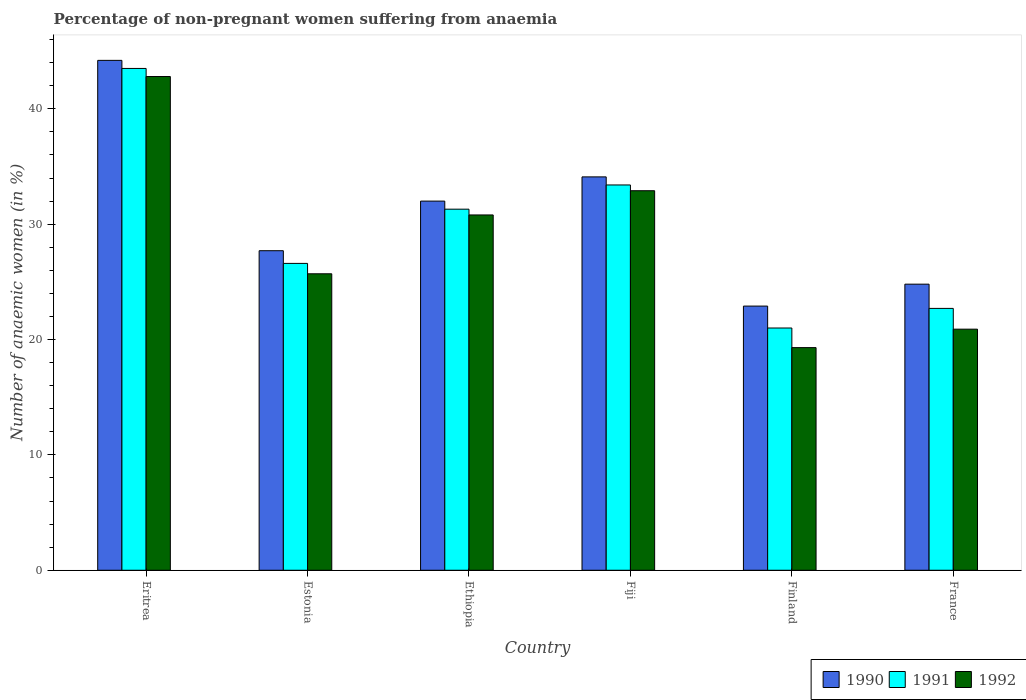How many different coloured bars are there?
Make the answer very short. 3. How many groups of bars are there?
Ensure brevity in your answer.  6. Are the number of bars on each tick of the X-axis equal?
Give a very brief answer. Yes. How many bars are there on the 5th tick from the right?
Provide a short and direct response. 3. What is the label of the 2nd group of bars from the left?
Provide a short and direct response. Estonia. What is the percentage of non-pregnant women suffering from anaemia in 1991 in Fiji?
Your answer should be very brief. 33.4. Across all countries, what is the maximum percentage of non-pregnant women suffering from anaemia in 1990?
Provide a succinct answer. 44.2. Across all countries, what is the minimum percentage of non-pregnant women suffering from anaemia in 1990?
Provide a short and direct response. 22.9. In which country was the percentage of non-pregnant women suffering from anaemia in 1990 maximum?
Give a very brief answer. Eritrea. In which country was the percentage of non-pregnant women suffering from anaemia in 1992 minimum?
Your answer should be very brief. Finland. What is the total percentage of non-pregnant women suffering from anaemia in 1991 in the graph?
Ensure brevity in your answer.  178.5. What is the difference between the percentage of non-pregnant women suffering from anaemia in 1990 in Finland and that in France?
Your answer should be very brief. -1.9. What is the average percentage of non-pregnant women suffering from anaemia in 1991 per country?
Keep it short and to the point. 29.75. In how many countries, is the percentage of non-pregnant women suffering from anaemia in 1992 greater than 44 %?
Provide a succinct answer. 0. What is the ratio of the percentage of non-pregnant women suffering from anaemia in 1991 in Eritrea to that in Estonia?
Provide a succinct answer. 1.64. Is the percentage of non-pregnant women suffering from anaemia in 1990 in Fiji less than that in France?
Your answer should be compact. No. What is the difference between the highest and the second highest percentage of non-pregnant women suffering from anaemia in 1990?
Give a very brief answer. -2.1. What is the difference between the highest and the lowest percentage of non-pregnant women suffering from anaemia in 1990?
Ensure brevity in your answer.  21.3. Is the sum of the percentage of non-pregnant women suffering from anaemia in 1991 in Eritrea and Fiji greater than the maximum percentage of non-pregnant women suffering from anaemia in 1992 across all countries?
Offer a very short reply. Yes. What does the 3rd bar from the right in Estonia represents?
Provide a succinct answer. 1990. Is it the case that in every country, the sum of the percentage of non-pregnant women suffering from anaemia in 1992 and percentage of non-pregnant women suffering from anaemia in 1991 is greater than the percentage of non-pregnant women suffering from anaemia in 1990?
Keep it short and to the point. Yes. How many bars are there?
Ensure brevity in your answer.  18. How many countries are there in the graph?
Your answer should be compact. 6. Are the values on the major ticks of Y-axis written in scientific E-notation?
Your answer should be compact. No. What is the title of the graph?
Your answer should be compact. Percentage of non-pregnant women suffering from anaemia. What is the label or title of the X-axis?
Provide a short and direct response. Country. What is the label or title of the Y-axis?
Your answer should be compact. Number of anaemic women (in %). What is the Number of anaemic women (in %) in 1990 in Eritrea?
Your answer should be compact. 44.2. What is the Number of anaemic women (in %) of 1991 in Eritrea?
Make the answer very short. 43.5. What is the Number of anaemic women (in %) of 1992 in Eritrea?
Your response must be concise. 42.8. What is the Number of anaemic women (in %) of 1990 in Estonia?
Make the answer very short. 27.7. What is the Number of anaemic women (in %) of 1991 in Estonia?
Your response must be concise. 26.6. What is the Number of anaemic women (in %) of 1992 in Estonia?
Make the answer very short. 25.7. What is the Number of anaemic women (in %) in 1991 in Ethiopia?
Your answer should be very brief. 31.3. What is the Number of anaemic women (in %) of 1992 in Ethiopia?
Offer a very short reply. 30.8. What is the Number of anaemic women (in %) of 1990 in Fiji?
Keep it short and to the point. 34.1. What is the Number of anaemic women (in %) in 1991 in Fiji?
Keep it short and to the point. 33.4. What is the Number of anaemic women (in %) of 1992 in Fiji?
Offer a terse response. 32.9. What is the Number of anaemic women (in %) of 1990 in Finland?
Give a very brief answer. 22.9. What is the Number of anaemic women (in %) in 1991 in Finland?
Your response must be concise. 21. What is the Number of anaemic women (in %) in 1992 in Finland?
Keep it short and to the point. 19.3. What is the Number of anaemic women (in %) in 1990 in France?
Ensure brevity in your answer.  24.8. What is the Number of anaemic women (in %) in 1991 in France?
Offer a terse response. 22.7. What is the Number of anaemic women (in %) of 1992 in France?
Your answer should be compact. 20.9. Across all countries, what is the maximum Number of anaemic women (in %) in 1990?
Your response must be concise. 44.2. Across all countries, what is the maximum Number of anaemic women (in %) of 1991?
Your response must be concise. 43.5. Across all countries, what is the maximum Number of anaemic women (in %) of 1992?
Keep it short and to the point. 42.8. Across all countries, what is the minimum Number of anaemic women (in %) in 1990?
Your answer should be very brief. 22.9. Across all countries, what is the minimum Number of anaemic women (in %) in 1991?
Give a very brief answer. 21. Across all countries, what is the minimum Number of anaemic women (in %) in 1992?
Your answer should be compact. 19.3. What is the total Number of anaemic women (in %) of 1990 in the graph?
Your answer should be very brief. 185.7. What is the total Number of anaemic women (in %) in 1991 in the graph?
Offer a terse response. 178.5. What is the total Number of anaemic women (in %) in 1992 in the graph?
Offer a terse response. 172.4. What is the difference between the Number of anaemic women (in %) of 1991 in Eritrea and that in Estonia?
Give a very brief answer. 16.9. What is the difference between the Number of anaemic women (in %) of 1992 in Eritrea and that in Estonia?
Provide a short and direct response. 17.1. What is the difference between the Number of anaemic women (in %) of 1991 in Eritrea and that in Ethiopia?
Your answer should be very brief. 12.2. What is the difference between the Number of anaemic women (in %) of 1992 in Eritrea and that in Ethiopia?
Give a very brief answer. 12. What is the difference between the Number of anaemic women (in %) of 1991 in Eritrea and that in Fiji?
Make the answer very short. 10.1. What is the difference between the Number of anaemic women (in %) of 1990 in Eritrea and that in Finland?
Provide a succinct answer. 21.3. What is the difference between the Number of anaemic women (in %) in 1991 in Eritrea and that in Finland?
Your response must be concise. 22.5. What is the difference between the Number of anaemic women (in %) of 1992 in Eritrea and that in Finland?
Offer a terse response. 23.5. What is the difference between the Number of anaemic women (in %) in 1990 in Eritrea and that in France?
Your answer should be compact. 19.4. What is the difference between the Number of anaemic women (in %) of 1991 in Eritrea and that in France?
Provide a short and direct response. 20.8. What is the difference between the Number of anaemic women (in %) in 1992 in Eritrea and that in France?
Provide a succinct answer. 21.9. What is the difference between the Number of anaemic women (in %) of 1991 in Estonia and that in Ethiopia?
Provide a short and direct response. -4.7. What is the difference between the Number of anaemic women (in %) in 1992 in Estonia and that in Ethiopia?
Offer a terse response. -5.1. What is the difference between the Number of anaemic women (in %) in 1991 in Estonia and that in Fiji?
Give a very brief answer. -6.8. What is the difference between the Number of anaemic women (in %) in 1992 in Estonia and that in Fiji?
Your answer should be compact. -7.2. What is the difference between the Number of anaemic women (in %) of 1990 in Estonia and that in Finland?
Keep it short and to the point. 4.8. What is the difference between the Number of anaemic women (in %) in 1991 in Estonia and that in Finland?
Keep it short and to the point. 5.6. What is the difference between the Number of anaemic women (in %) in 1992 in Estonia and that in Finland?
Make the answer very short. 6.4. What is the difference between the Number of anaemic women (in %) in 1990 in Estonia and that in France?
Keep it short and to the point. 2.9. What is the difference between the Number of anaemic women (in %) of 1992 in Estonia and that in France?
Your response must be concise. 4.8. What is the difference between the Number of anaemic women (in %) in 1991 in Ethiopia and that in Fiji?
Offer a very short reply. -2.1. What is the difference between the Number of anaemic women (in %) in 1991 in Ethiopia and that in Finland?
Provide a succinct answer. 10.3. What is the difference between the Number of anaemic women (in %) of 1992 in Ethiopia and that in Finland?
Give a very brief answer. 11.5. What is the difference between the Number of anaemic women (in %) of 1990 in Ethiopia and that in France?
Offer a very short reply. 7.2. What is the difference between the Number of anaemic women (in %) in 1991 in Ethiopia and that in France?
Provide a succinct answer. 8.6. What is the difference between the Number of anaemic women (in %) of 1990 in Fiji and that in Finland?
Offer a terse response. 11.2. What is the difference between the Number of anaemic women (in %) in 1991 in Fiji and that in Finland?
Make the answer very short. 12.4. What is the difference between the Number of anaemic women (in %) of 1991 in Fiji and that in France?
Your answer should be compact. 10.7. What is the difference between the Number of anaemic women (in %) of 1990 in Eritrea and the Number of anaemic women (in %) of 1992 in Estonia?
Keep it short and to the point. 18.5. What is the difference between the Number of anaemic women (in %) of 1990 in Eritrea and the Number of anaemic women (in %) of 1992 in Ethiopia?
Keep it short and to the point. 13.4. What is the difference between the Number of anaemic women (in %) of 1990 in Eritrea and the Number of anaemic women (in %) of 1991 in Finland?
Provide a succinct answer. 23.2. What is the difference between the Number of anaemic women (in %) in 1990 in Eritrea and the Number of anaemic women (in %) in 1992 in Finland?
Offer a terse response. 24.9. What is the difference between the Number of anaemic women (in %) of 1991 in Eritrea and the Number of anaemic women (in %) of 1992 in Finland?
Provide a short and direct response. 24.2. What is the difference between the Number of anaemic women (in %) in 1990 in Eritrea and the Number of anaemic women (in %) in 1992 in France?
Give a very brief answer. 23.3. What is the difference between the Number of anaemic women (in %) in 1991 in Eritrea and the Number of anaemic women (in %) in 1992 in France?
Provide a succinct answer. 22.6. What is the difference between the Number of anaemic women (in %) in 1990 in Estonia and the Number of anaemic women (in %) in 1992 in Ethiopia?
Give a very brief answer. -3.1. What is the difference between the Number of anaemic women (in %) in 1990 in Estonia and the Number of anaemic women (in %) in 1991 in Fiji?
Make the answer very short. -5.7. What is the difference between the Number of anaemic women (in %) in 1990 in Estonia and the Number of anaemic women (in %) in 1992 in Fiji?
Your answer should be compact. -5.2. What is the difference between the Number of anaemic women (in %) in 1990 in Estonia and the Number of anaemic women (in %) in 1991 in France?
Your answer should be compact. 5. What is the difference between the Number of anaemic women (in %) of 1990 in Estonia and the Number of anaemic women (in %) of 1992 in France?
Offer a very short reply. 6.8. What is the difference between the Number of anaemic women (in %) of 1991 in Estonia and the Number of anaemic women (in %) of 1992 in France?
Your answer should be compact. 5.7. What is the difference between the Number of anaemic women (in %) of 1991 in Ethiopia and the Number of anaemic women (in %) of 1992 in Fiji?
Make the answer very short. -1.6. What is the difference between the Number of anaemic women (in %) of 1990 in Ethiopia and the Number of anaemic women (in %) of 1992 in France?
Your answer should be very brief. 11.1. What is the difference between the Number of anaemic women (in %) in 1990 in Fiji and the Number of anaemic women (in %) in 1991 in Finland?
Ensure brevity in your answer.  13.1. What is the difference between the Number of anaemic women (in %) in 1990 in Fiji and the Number of anaemic women (in %) in 1992 in Finland?
Your answer should be compact. 14.8. What is the difference between the Number of anaemic women (in %) of 1990 in Fiji and the Number of anaemic women (in %) of 1991 in France?
Your response must be concise. 11.4. What is the difference between the Number of anaemic women (in %) of 1991 in Fiji and the Number of anaemic women (in %) of 1992 in France?
Provide a succinct answer. 12.5. What is the difference between the Number of anaemic women (in %) in 1990 in Finland and the Number of anaemic women (in %) in 1991 in France?
Offer a very short reply. 0.2. What is the average Number of anaemic women (in %) in 1990 per country?
Your answer should be compact. 30.95. What is the average Number of anaemic women (in %) in 1991 per country?
Your answer should be very brief. 29.75. What is the average Number of anaemic women (in %) of 1992 per country?
Keep it short and to the point. 28.73. What is the difference between the Number of anaemic women (in %) in 1990 and Number of anaemic women (in %) in 1991 in Eritrea?
Your answer should be very brief. 0.7. What is the difference between the Number of anaemic women (in %) of 1991 and Number of anaemic women (in %) of 1992 in Eritrea?
Provide a short and direct response. 0.7. What is the difference between the Number of anaemic women (in %) in 1991 and Number of anaemic women (in %) in 1992 in Estonia?
Your answer should be very brief. 0.9. What is the difference between the Number of anaemic women (in %) in 1990 and Number of anaemic women (in %) in 1991 in Ethiopia?
Your answer should be very brief. 0.7. What is the difference between the Number of anaemic women (in %) in 1990 and Number of anaemic women (in %) in 1992 in Ethiopia?
Offer a very short reply. 1.2. What is the difference between the Number of anaemic women (in %) in 1991 and Number of anaemic women (in %) in 1992 in Ethiopia?
Provide a short and direct response. 0.5. What is the difference between the Number of anaemic women (in %) of 1990 and Number of anaemic women (in %) of 1991 in Fiji?
Ensure brevity in your answer.  0.7. What is the difference between the Number of anaemic women (in %) in 1990 and Number of anaemic women (in %) in 1991 in Finland?
Give a very brief answer. 1.9. What is the difference between the Number of anaemic women (in %) of 1991 and Number of anaemic women (in %) of 1992 in Finland?
Your answer should be very brief. 1.7. What is the difference between the Number of anaemic women (in %) in 1990 and Number of anaemic women (in %) in 1991 in France?
Make the answer very short. 2.1. What is the difference between the Number of anaemic women (in %) in 1990 and Number of anaemic women (in %) in 1992 in France?
Ensure brevity in your answer.  3.9. What is the difference between the Number of anaemic women (in %) of 1991 and Number of anaemic women (in %) of 1992 in France?
Your answer should be compact. 1.8. What is the ratio of the Number of anaemic women (in %) of 1990 in Eritrea to that in Estonia?
Keep it short and to the point. 1.6. What is the ratio of the Number of anaemic women (in %) in 1991 in Eritrea to that in Estonia?
Provide a succinct answer. 1.64. What is the ratio of the Number of anaemic women (in %) in 1992 in Eritrea to that in Estonia?
Your answer should be compact. 1.67. What is the ratio of the Number of anaemic women (in %) of 1990 in Eritrea to that in Ethiopia?
Provide a short and direct response. 1.38. What is the ratio of the Number of anaemic women (in %) of 1991 in Eritrea to that in Ethiopia?
Your answer should be very brief. 1.39. What is the ratio of the Number of anaemic women (in %) in 1992 in Eritrea to that in Ethiopia?
Your response must be concise. 1.39. What is the ratio of the Number of anaemic women (in %) of 1990 in Eritrea to that in Fiji?
Keep it short and to the point. 1.3. What is the ratio of the Number of anaemic women (in %) of 1991 in Eritrea to that in Fiji?
Your response must be concise. 1.3. What is the ratio of the Number of anaemic women (in %) in 1992 in Eritrea to that in Fiji?
Your answer should be very brief. 1.3. What is the ratio of the Number of anaemic women (in %) of 1990 in Eritrea to that in Finland?
Give a very brief answer. 1.93. What is the ratio of the Number of anaemic women (in %) of 1991 in Eritrea to that in Finland?
Provide a short and direct response. 2.07. What is the ratio of the Number of anaemic women (in %) of 1992 in Eritrea to that in Finland?
Your answer should be very brief. 2.22. What is the ratio of the Number of anaemic women (in %) of 1990 in Eritrea to that in France?
Ensure brevity in your answer.  1.78. What is the ratio of the Number of anaemic women (in %) of 1991 in Eritrea to that in France?
Provide a short and direct response. 1.92. What is the ratio of the Number of anaemic women (in %) of 1992 in Eritrea to that in France?
Your answer should be very brief. 2.05. What is the ratio of the Number of anaemic women (in %) of 1990 in Estonia to that in Ethiopia?
Provide a succinct answer. 0.87. What is the ratio of the Number of anaemic women (in %) in 1991 in Estonia to that in Ethiopia?
Your answer should be very brief. 0.85. What is the ratio of the Number of anaemic women (in %) of 1992 in Estonia to that in Ethiopia?
Your response must be concise. 0.83. What is the ratio of the Number of anaemic women (in %) in 1990 in Estonia to that in Fiji?
Make the answer very short. 0.81. What is the ratio of the Number of anaemic women (in %) in 1991 in Estonia to that in Fiji?
Offer a terse response. 0.8. What is the ratio of the Number of anaemic women (in %) in 1992 in Estonia to that in Fiji?
Your answer should be very brief. 0.78. What is the ratio of the Number of anaemic women (in %) in 1990 in Estonia to that in Finland?
Offer a terse response. 1.21. What is the ratio of the Number of anaemic women (in %) of 1991 in Estonia to that in Finland?
Offer a terse response. 1.27. What is the ratio of the Number of anaemic women (in %) in 1992 in Estonia to that in Finland?
Offer a terse response. 1.33. What is the ratio of the Number of anaemic women (in %) in 1990 in Estonia to that in France?
Keep it short and to the point. 1.12. What is the ratio of the Number of anaemic women (in %) of 1991 in Estonia to that in France?
Make the answer very short. 1.17. What is the ratio of the Number of anaemic women (in %) in 1992 in Estonia to that in France?
Offer a very short reply. 1.23. What is the ratio of the Number of anaemic women (in %) of 1990 in Ethiopia to that in Fiji?
Keep it short and to the point. 0.94. What is the ratio of the Number of anaemic women (in %) in 1991 in Ethiopia to that in Fiji?
Make the answer very short. 0.94. What is the ratio of the Number of anaemic women (in %) in 1992 in Ethiopia to that in Fiji?
Your answer should be very brief. 0.94. What is the ratio of the Number of anaemic women (in %) in 1990 in Ethiopia to that in Finland?
Make the answer very short. 1.4. What is the ratio of the Number of anaemic women (in %) in 1991 in Ethiopia to that in Finland?
Offer a very short reply. 1.49. What is the ratio of the Number of anaemic women (in %) in 1992 in Ethiopia to that in Finland?
Give a very brief answer. 1.6. What is the ratio of the Number of anaemic women (in %) of 1990 in Ethiopia to that in France?
Provide a succinct answer. 1.29. What is the ratio of the Number of anaemic women (in %) in 1991 in Ethiopia to that in France?
Ensure brevity in your answer.  1.38. What is the ratio of the Number of anaemic women (in %) in 1992 in Ethiopia to that in France?
Provide a succinct answer. 1.47. What is the ratio of the Number of anaemic women (in %) in 1990 in Fiji to that in Finland?
Your answer should be very brief. 1.49. What is the ratio of the Number of anaemic women (in %) in 1991 in Fiji to that in Finland?
Offer a terse response. 1.59. What is the ratio of the Number of anaemic women (in %) of 1992 in Fiji to that in Finland?
Your answer should be compact. 1.7. What is the ratio of the Number of anaemic women (in %) of 1990 in Fiji to that in France?
Provide a short and direct response. 1.38. What is the ratio of the Number of anaemic women (in %) in 1991 in Fiji to that in France?
Keep it short and to the point. 1.47. What is the ratio of the Number of anaemic women (in %) in 1992 in Fiji to that in France?
Your answer should be compact. 1.57. What is the ratio of the Number of anaemic women (in %) of 1990 in Finland to that in France?
Your response must be concise. 0.92. What is the ratio of the Number of anaemic women (in %) in 1991 in Finland to that in France?
Offer a very short reply. 0.93. What is the ratio of the Number of anaemic women (in %) in 1992 in Finland to that in France?
Your answer should be compact. 0.92. What is the difference between the highest and the second highest Number of anaemic women (in %) in 1990?
Provide a succinct answer. 10.1. What is the difference between the highest and the second highest Number of anaemic women (in %) of 1991?
Your response must be concise. 10.1. What is the difference between the highest and the second highest Number of anaemic women (in %) in 1992?
Provide a succinct answer. 9.9. What is the difference between the highest and the lowest Number of anaemic women (in %) of 1990?
Your answer should be very brief. 21.3. What is the difference between the highest and the lowest Number of anaemic women (in %) in 1991?
Ensure brevity in your answer.  22.5. 